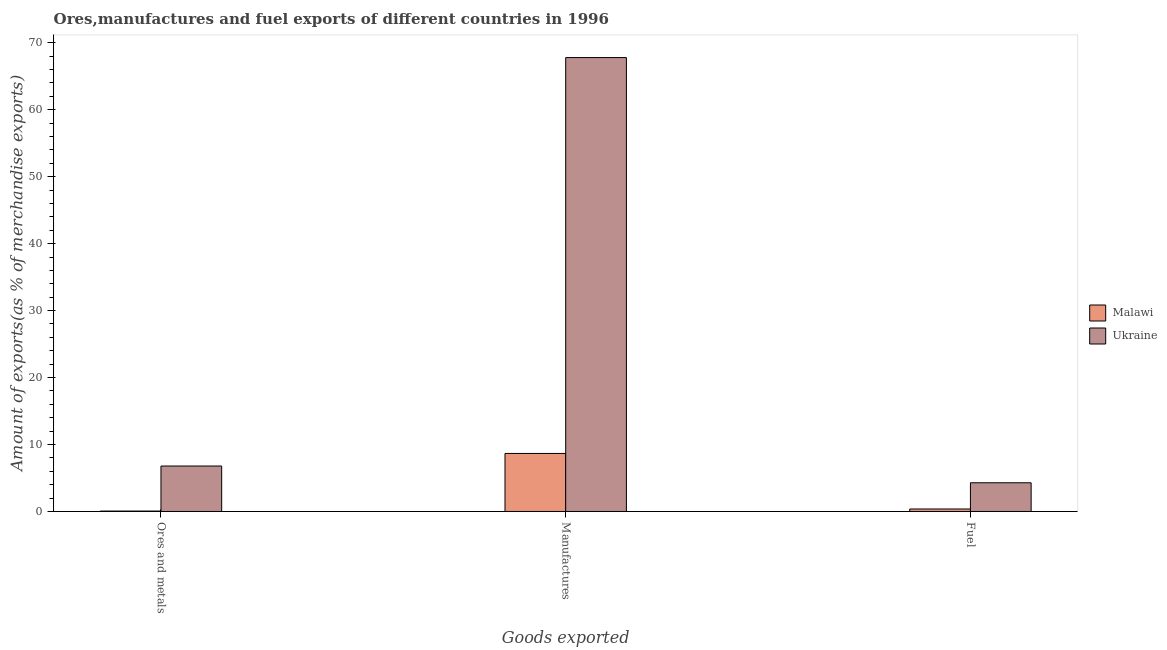How many different coloured bars are there?
Provide a short and direct response. 2. Are the number of bars per tick equal to the number of legend labels?
Offer a terse response. Yes. How many bars are there on the 1st tick from the left?
Your answer should be compact. 2. How many bars are there on the 1st tick from the right?
Provide a succinct answer. 2. What is the label of the 3rd group of bars from the left?
Offer a very short reply. Fuel. What is the percentage of manufactures exports in Malawi?
Give a very brief answer. 8.67. Across all countries, what is the maximum percentage of fuel exports?
Give a very brief answer. 4.29. Across all countries, what is the minimum percentage of fuel exports?
Offer a very short reply. 0.37. In which country was the percentage of fuel exports maximum?
Ensure brevity in your answer.  Ukraine. In which country was the percentage of fuel exports minimum?
Keep it short and to the point. Malawi. What is the total percentage of ores and metals exports in the graph?
Ensure brevity in your answer.  6.85. What is the difference between the percentage of ores and metals exports in Malawi and that in Ukraine?
Keep it short and to the point. -6.73. What is the difference between the percentage of fuel exports in Ukraine and the percentage of ores and metals exports in Malawi?
Your response must be concise. 4.23. What is the average percentage of fuel exports per country?
Provide a succinct answer. 2.33. What is the difference between the percentage of manufactures exports and percentage of ores and metals exports in Malawi?
Make the answer very short. 8.6. In how many countries, is the percentage of manufactures exports greater than 54 %?
Provide a short and direct response. 1. What is the ratio of the percentage of fuel exports in Malawi to that in Ukraine?
Ensure brevity in your answer.  0.09. Is the percentage of ores and metals exports in Ukraine less than that in Malawi?
Provide a short and direct response. No. What is the difference between the highest and the second highest percentage of fuel exports?
Make the answer very short. 3.92. What is the difference between the highest and the lowest percentage of ores and metals exports?
Offer a very short reply. 6.73. In how many countries, is the percentage of ores and metals exports greater than the average percentage of ores and metals exports taken over all countries?
Your response must be concise. 1. What does the 2nd bar from the left in Ores and metals represents?
Give a very brief answer. Ukraine. What does the 1st bar from the right in Manufactures represents?
Keep it short and to the point. Ukraine. Is it the case that in every country, the sum of the percentage of ores and metals exports and percentage of manufactures exports is greater than the percentage of fuel exports?
Make the answer very short. Yes. How many countries are there in the graph?
Your response must be concise. 2. What is the difference between two consecutive major ticks on the Y-axis?
Your response must be concise. 10. Are the values on the major ticks of Y-axis written in scientific E-notation?
Keep it short and to the point. No. Does the graph contain any zero values?
Provide a short and direct response. No. Where does the legend appear in the graph?
Offer a very short reply. Center right. How many legend labels are there?
Offer a very short reply. 2. What is the title of the graph?
Give a very brief answer. Ores,manufactures and fuel exports of different countries in 1996. Does "Isle of Man" appear as one of the legend labels in the graph?
Keep it short and to the point. No. What is the label or title of the X-axis?
Offer a terse response. Goods exported. What is the label or title of the Y-axis?
Your answer should be very brief. Amount of exports(as % of merchandise exports). What is the Amount of exports(as % of merchandise exports) of Malawi in Ores and metals?
Offer a very short reply. 0.06. What is the Amount of exports(as % of merchandise exports) in Ukraine in Ores and metals?
Provide a succinct answer. 6.79. What is the Amount of exports(as % of merchandise exports) of Malawi in Manufactures?
Keep it short and to the point. 8.67. What is the Amount of exports(as % of merchandise exports) in Ukraine in Manufactures?
Offer a terse response. 67.79. What is the Amount of exports(as % of merchandise exports) of Malawi in Fuel?
Give a very brief answer. 0.37. What is the Amount of exports(as % of merchandise exports) of Ukraine in Fuel?
Your answer should be very brief. 4.29. Across all Goods exported, what is the maximum Amount of exports(as % of merchandise exports) in Malawi?
Ensure brevity in your answer.  8.67. Across all Goods exported, what is the maximum Amount of exports(as % of merchandise exports) in Ukraine?
Offer a terse response. 67.79. Across all Goods exported, what is the minimum Amount of exports(as % of merchandise exports) in Malawi?
Offer a terse response. 0.06. Across all Goods exported, what is the minimum Amount of exports(as % of merchandise exports) of Ukraine?
Make the answer very short. 4.29. What is the total Amount of exports(as % of merchandise exports) in Malawi in the graph?
Keep it short and to the point. 9.1. What is the total Amount of exports(as % of merchandise exports) of Ukraine in the graph?
Offer a very short reply. 78.87. What is the difference between the Amount of exports(as % of merchandise exports) of Malawi in Ores and metals and that in Manufactures?
Your answer should be very brief. -8.6. What is the difference between the Amount of exports(as % of merchandise exports) of Ukraine in Ores and metals and that in Manufactures?
Keep it short and to the point. -61. What is the difference between the Amount of exports(as % of merchandise exports) of Malawi in Ores and metals and that in Fuel?
Keep it short and to the point. -0.31. What is the difference between the Amount of exports(as % of merchandise exports) in Ukraine in Ores and metals and that in Fuel?
Offer a terse response. 2.5. What is the difference between the Amount of exports(as % of merchandise exports) in Malawi in Manufactures and that in Fuel?
Your answer should be very brief. 8.3. What is the difference between the Amount of exports(as % of merchandise exports) in Ukraine in Manufactures and that in Fuel?
Provide a short and direct response. 63.5. What is the difference between the Amount of exports(as % of merchandise exports) in Malawi in Ores and metals and the Amount of exports(as % of merchandise exports) in Ukraine in Manufactures?
Provide a short and direct response. -67.73. What is the difference between the Amount of exports(as % of merchandise exports) of Malawi in Ores and metals and the Amount of exports(as % of merchandise exports) of Ukraine in Fuel?
Your response must be concise. -4.23. What is the difference between the Amount of exports(as % of merchandise exports) of Malawi in Manufactures and the Amount of exports(as % of merchandise exports) of Ukraine in Fuel?
Your answer should be very brief. 4.38. What is the average Amount of exports(as % of merchandise exports) of Malawi per Goods exported?
Provide a short and direct response. 3.03. What is the average Amount of exports(as % of merchandise exports) in Ukraine per Goods exported?
Provide a short and direct response. 26.29. What is the difference between the Amount of exports(as % of merchandise exports) of Malawi and Amount of exports(as % of merchandise exports) of Ukraine in Ores and metals?
Your answer should be compact. -6.73. What is the difference between the Amount of exports(as % of merchandise exports) in Malawi and Amount of exports(as % of merchandise exports) in Ukraine in Manufactures?
Give a very brief answer. -59.12. What is the difference between the Amount of exports(as % of merchandise exports) in Malawi and Amount of exports(as % of merchandise exports) in Ukraine in Fuel?
Your response must be concise. -3.92. What is the ratio of the Amount of exports(as % of merchandise exports) in Malawi in Ores and metals to that in Manufactures?
Your answer should be compact. 0.01. What is the ratio of the Amount of exports(as % of merchandise exports) of Ukraine in Ores and metals to that in Manufactures?
Provide a succinct answer. 0.1. What is the ratio of the Amount of exports(as % of merchandise exports) in Malawi in Ores and metals to that in Fuel?
Give a very brief answer. 0.17. What is the ratio of the Amount of exports(as % of merchandise exports) of Ukraine in Ores and metals to that in Fuel?
Offer a very short reply. 1.58. What is the ratio of the Amount of exports(as % of merchandise exports) of Malawi in Manufactures to that in Fuel?
Ensure brevity in your answer.  23.3. What is the ratio of the Amount of exports(as % of merchandise exports) in Ukraine in Manufactures to that in Fuel?
Offer a terse response. 15.81. What is the difference between the highest and the second highest Amount of exports(as % of merchandise exports) in Malawi?
Offer a very short reply. 8.3. What is the difference between the highest and the second highest Amount of exports(as % of merchandise exports) in Ukraine?
Your answer should be very brief. 61. What is the difference between the highest and the lowest Amount of exports(as % of merchandise exports) in Malawi?
Make the answer very short. 8.6. What is the difference between the highest and the lowest Amount of exports(as % of merchandise exports) of Ukraine?
Keep it short and to the point. 63.5. 